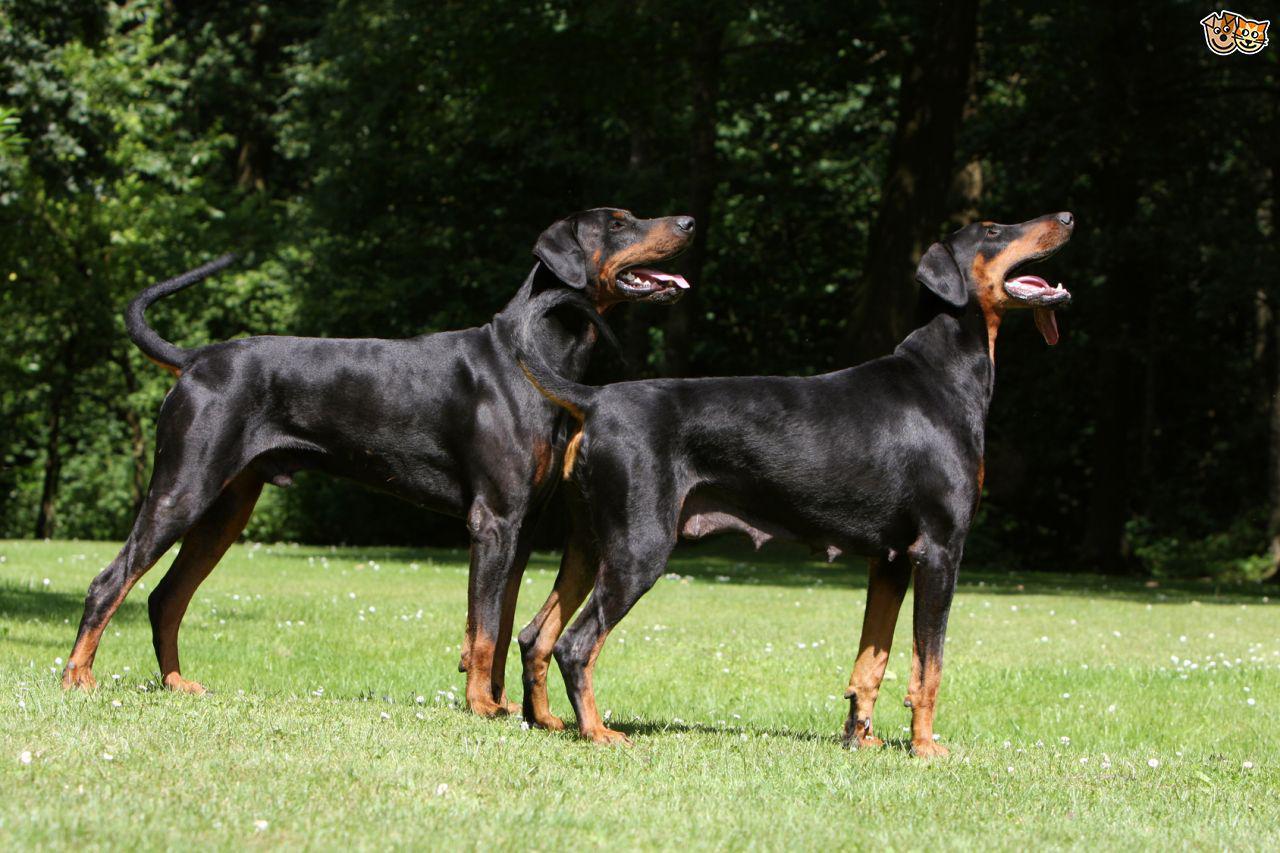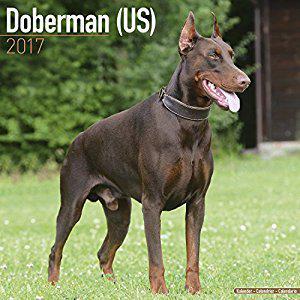The first image is the image on the left, the second image is the image on the right. For the images shown, is this caption "The dog in the image on the left has its mouth closed." true? Answer yes or no. No. The first image is the image on the left, the second image is the image on the right. For the images displayed, is the sentence "There are dogs standing in each image" factually correct? Answer yes or no. Yes. 